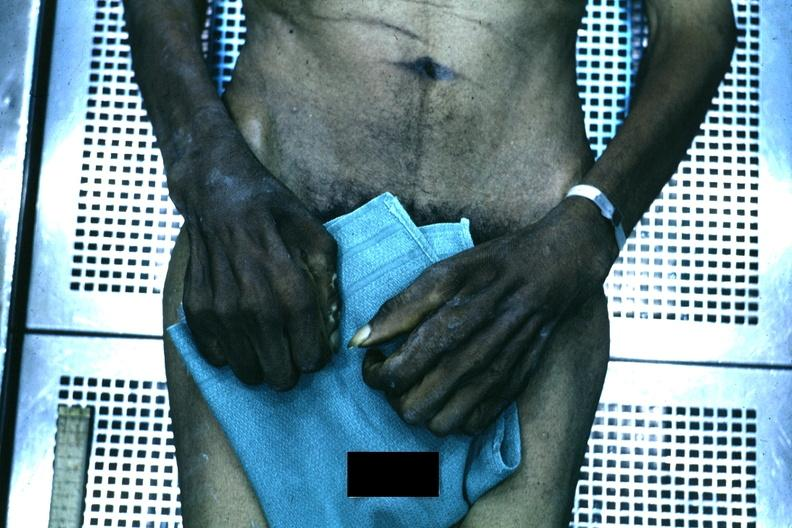s hand present?
Answer the question using a single word or phrase. Yes 